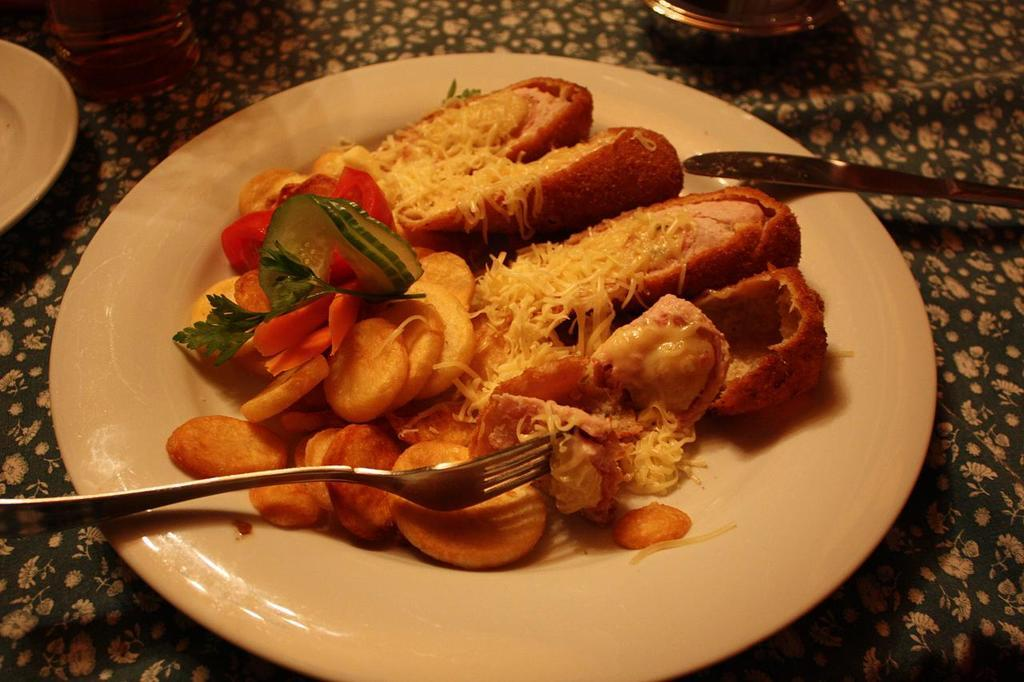What utensil is visible in the image? There is a fork in the image. What is on the plate in the image? There is a food item on a plate in the image. What color is the plate? The plate is white in the image. What else can be seen on the surface in the image? There are other objects on a surface in the image. How is the surface covered? The surface is covered with a cloth. What type of oven is visible in the image? There is no oven present in the image. The image features a fork, a plate with food, and other objects on a surface covered with a cloth. 